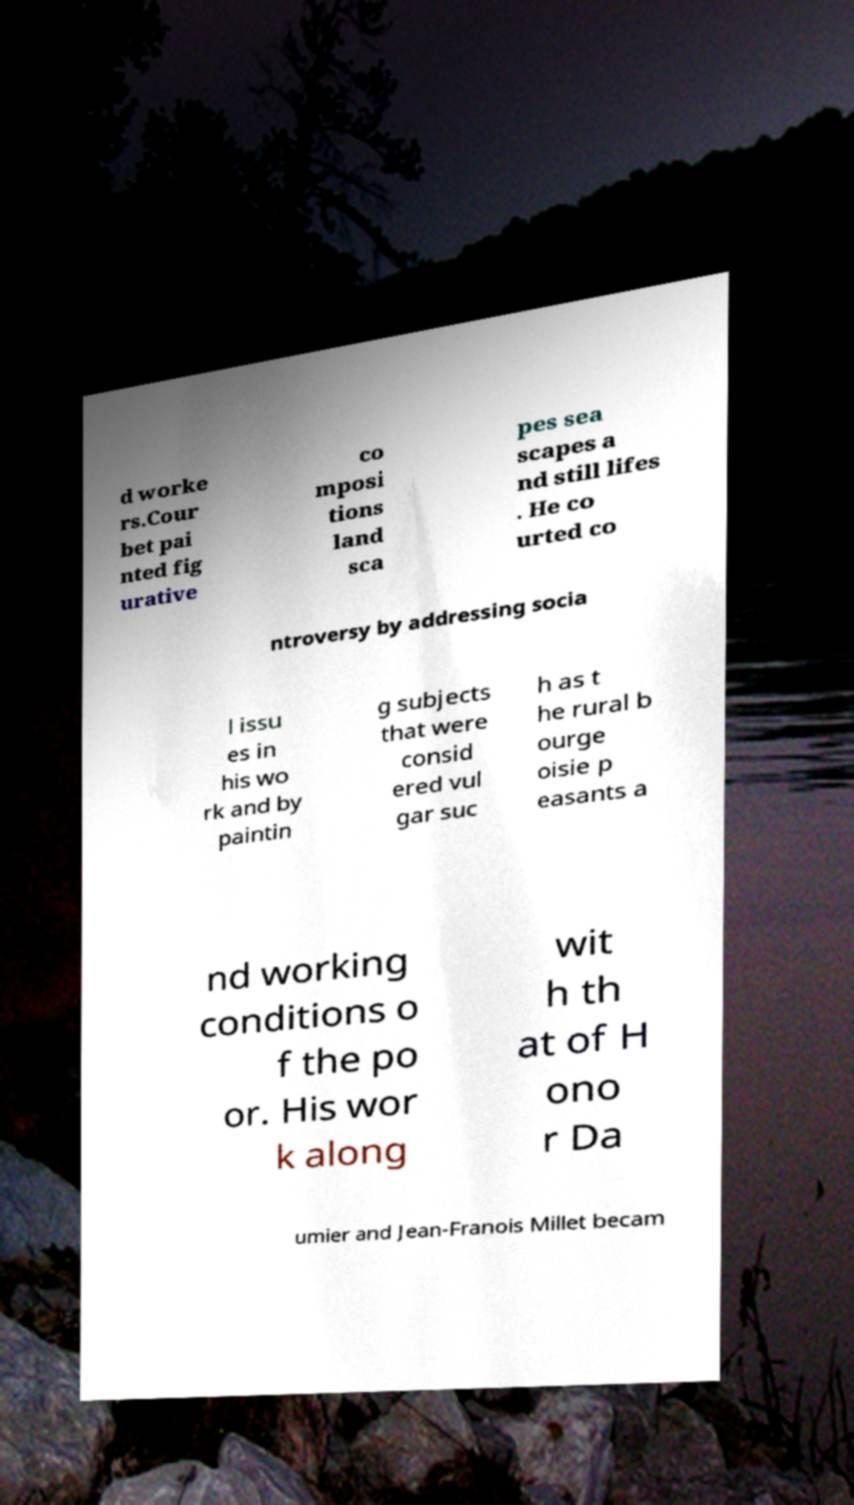Please read and relay the text visible in this image. What does it say? d worke rs.Cour bet pai nted fig urative co mposi tions land sca pes sea scapes a nd still lifes . He co urted co ntroversy by addressing socia l issu es in his wo rk and by paintin g subjects that were consid ered vul gar suc h as t he rural b ourge oisie p easants a nd working conditions o f the po or. His wor k along wit h th at of H ono r Da umier and Jean-Franois Millet becam 